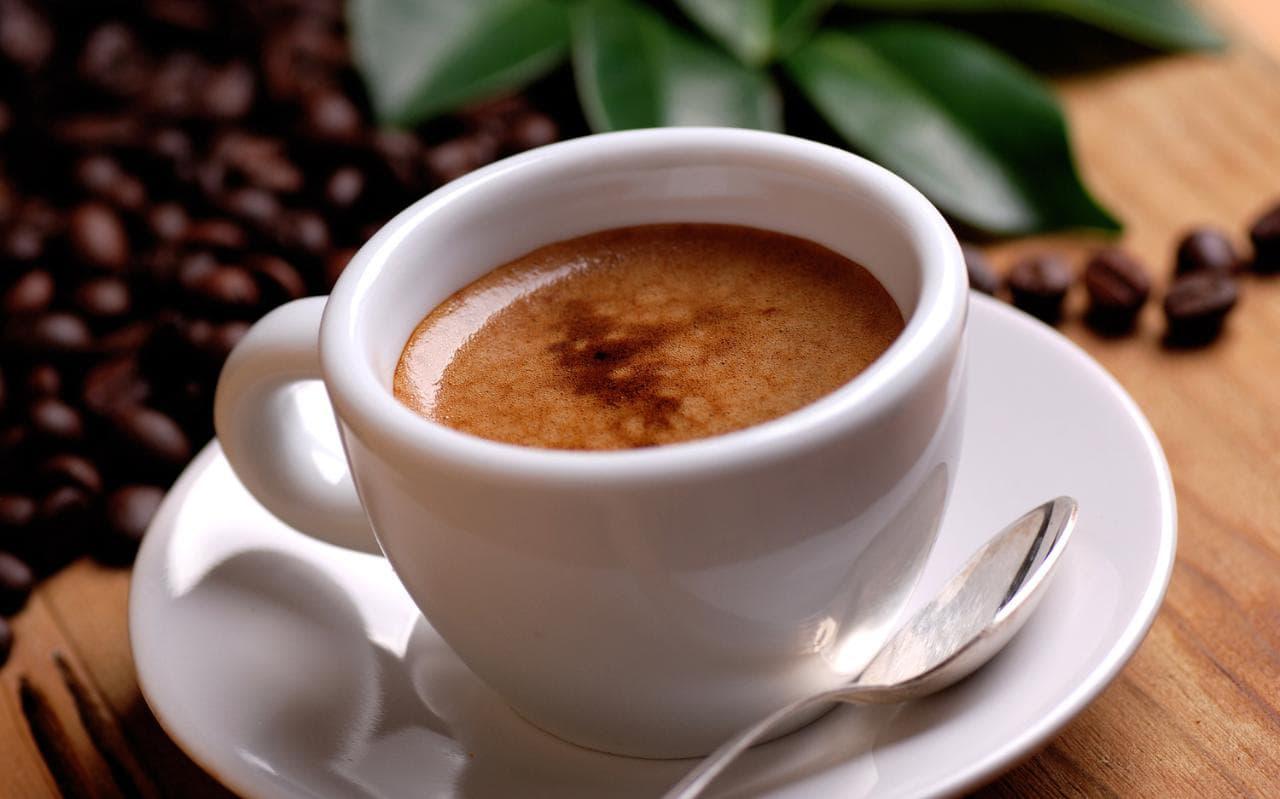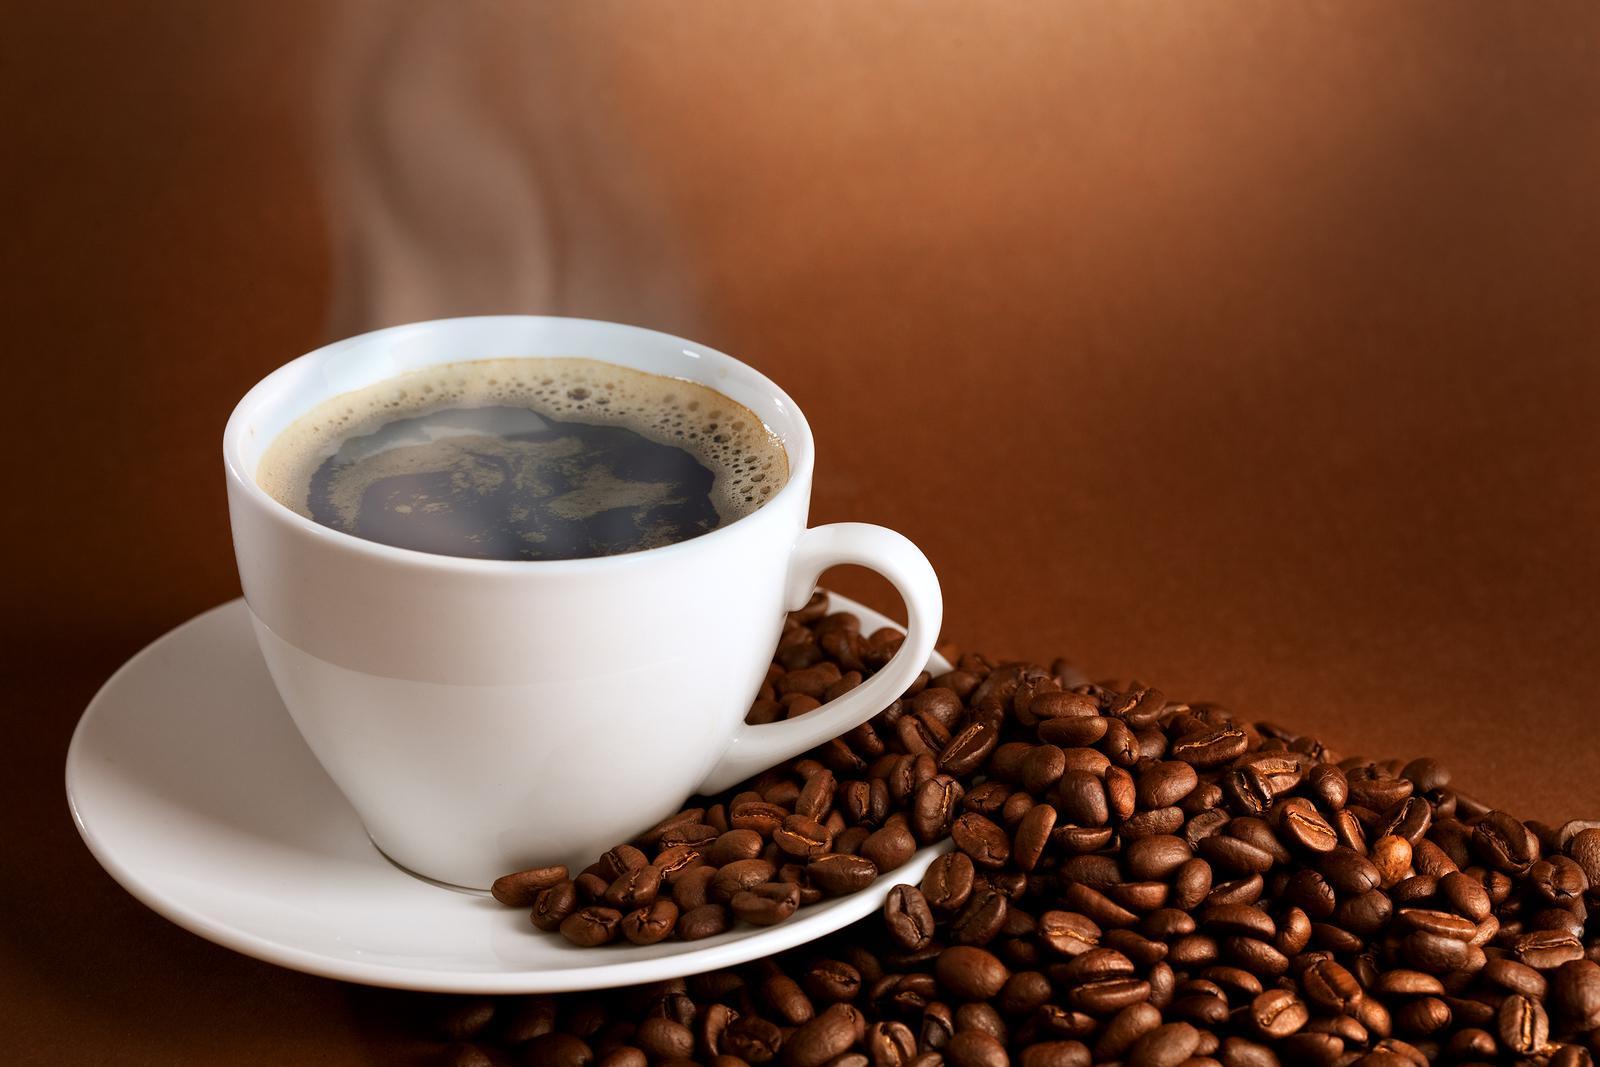The first image is the image on the left, the second image is the image on the right. Considering the images on both sides, is "Each image shows two matching hot drinks in cups, one of the pairs, cups of coffee with heart shaped froth designs." valid? Answer yes or no. No. 